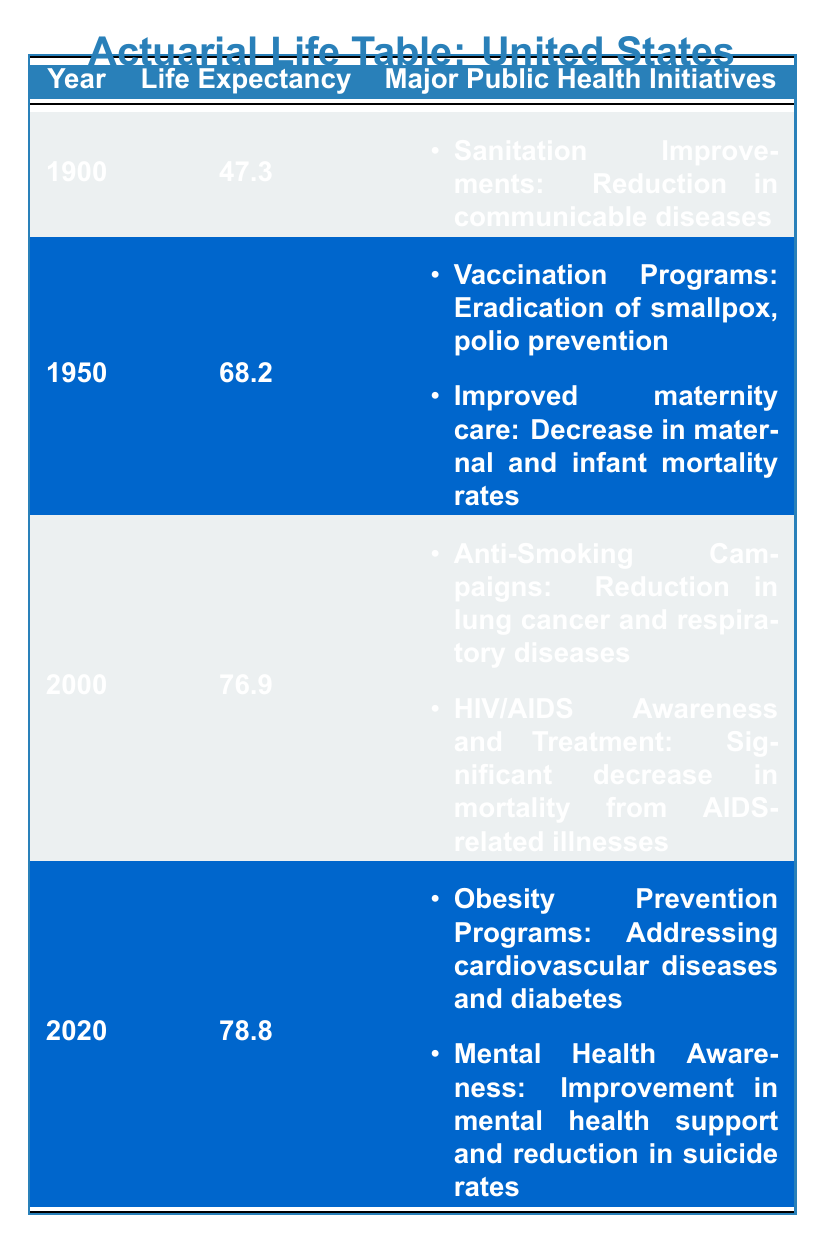What was the life expectancy in 1900? The life expectancy for the year 1900 is directly stated in the table, which shows it as 47.3 years.
Answer: 47.3 Which public health initiative contributed to the increase in life expectancy from 1900 to 1950? In the transition from 1900 to 1950, one key public health initiative was "Vaccination Programs," which included the eradication of smallpox and polio prevention, and improved maternity care that decreased maternal and infant mortality rates.
Answer: Vaccination Programs What was the life expectancy in 2000, and what were the major public health initiatives in that year? The life expectancy in 2000 is shown in the table as 76.9 years. The major public health initiatives for that year include "Anti-Smoking Campaigns" and "HIV/AIDS Awareness and Treatment."
Answer: 76.9, Anti-Smoking Campaigns and HIV/AIDS Awareness Is it true that life expectancy decreased from 1950 to 2000? To assess this, we compare the life expectancies: it was 68.2 years in 1950 and increased to 76.9 years in 2000. Therefore, life expectancy did not decrease; it actually increased.
Answer: No What is the average life expectancy across all years listed in the table? To find the average, sum the life expectancies: (47.3 + 68.2 + 76.9 + 78.8) = 271.2. There are 4 data points, so the average is 271.2 / 4 = 67.8.
Answer: 67.8 Which health initiative was aimed at reducing suicide rates, and in which year was it implemented? The health initiative aimed at reducing suicide rates is "Mental Health Awareness," and it was implemented in 2020, as seen in the table.
Answer: Mental Health Awareness, 2020 By how much did life expectancy increase from 2000 to 2020? The life expectancy in 2000 was 76.9 years and in 2020 was 78.8 years. To find the increase, we subtract: 78.8 - 76.9 = 1.9 years.
Answer: 1.9 years Did any public health initiative in 1950 focus on improving maternal care? Yes, the table indicates that there was a public health initiative called "Improved maternity care," aimed at decreasing maternal and infant mortality rates in 1950.
Answer: Yes Name one public health initiative from 2020 and explain its impact based on the table. One public health initiative from 2020 is "Obesity Prevention Programs," which impact cardiovascular diseases and diabetes, as noted in the table.
Answer: Obesity Prevention Programs, cardiovascular diseases and diabetes 